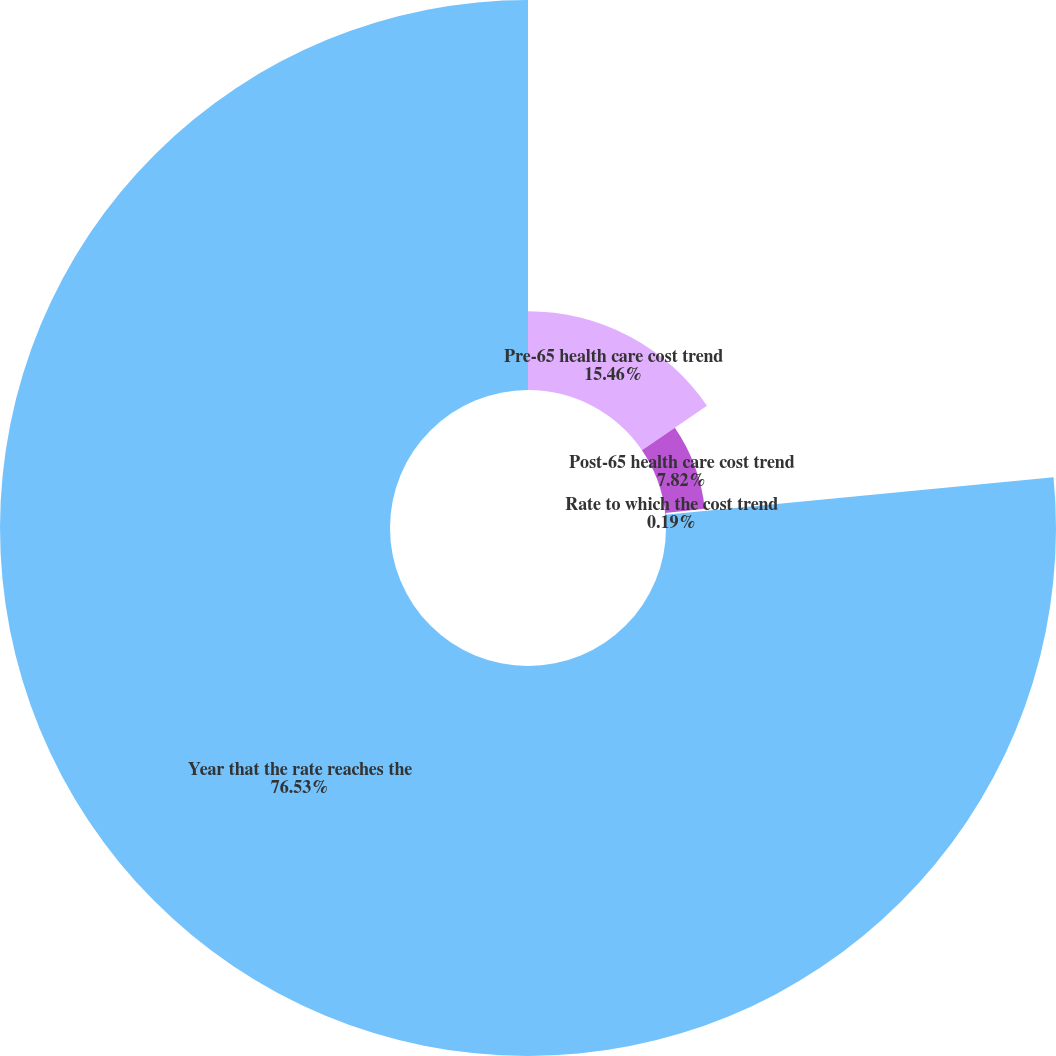Convert chart to OTSL. <chart><loc_0><loc_0><loc_500><loc_500><pie_chart><fcel>Pre-65 health care cost trend<fcel>Post-65 health care cost trend<fcel>Rate to which the cost trend<fcel>Year that the rate reaches the<nl><fcel>15.46%<fcel>7.82%<fcel>0.19%<fcel>76.53%<nl></chart> 